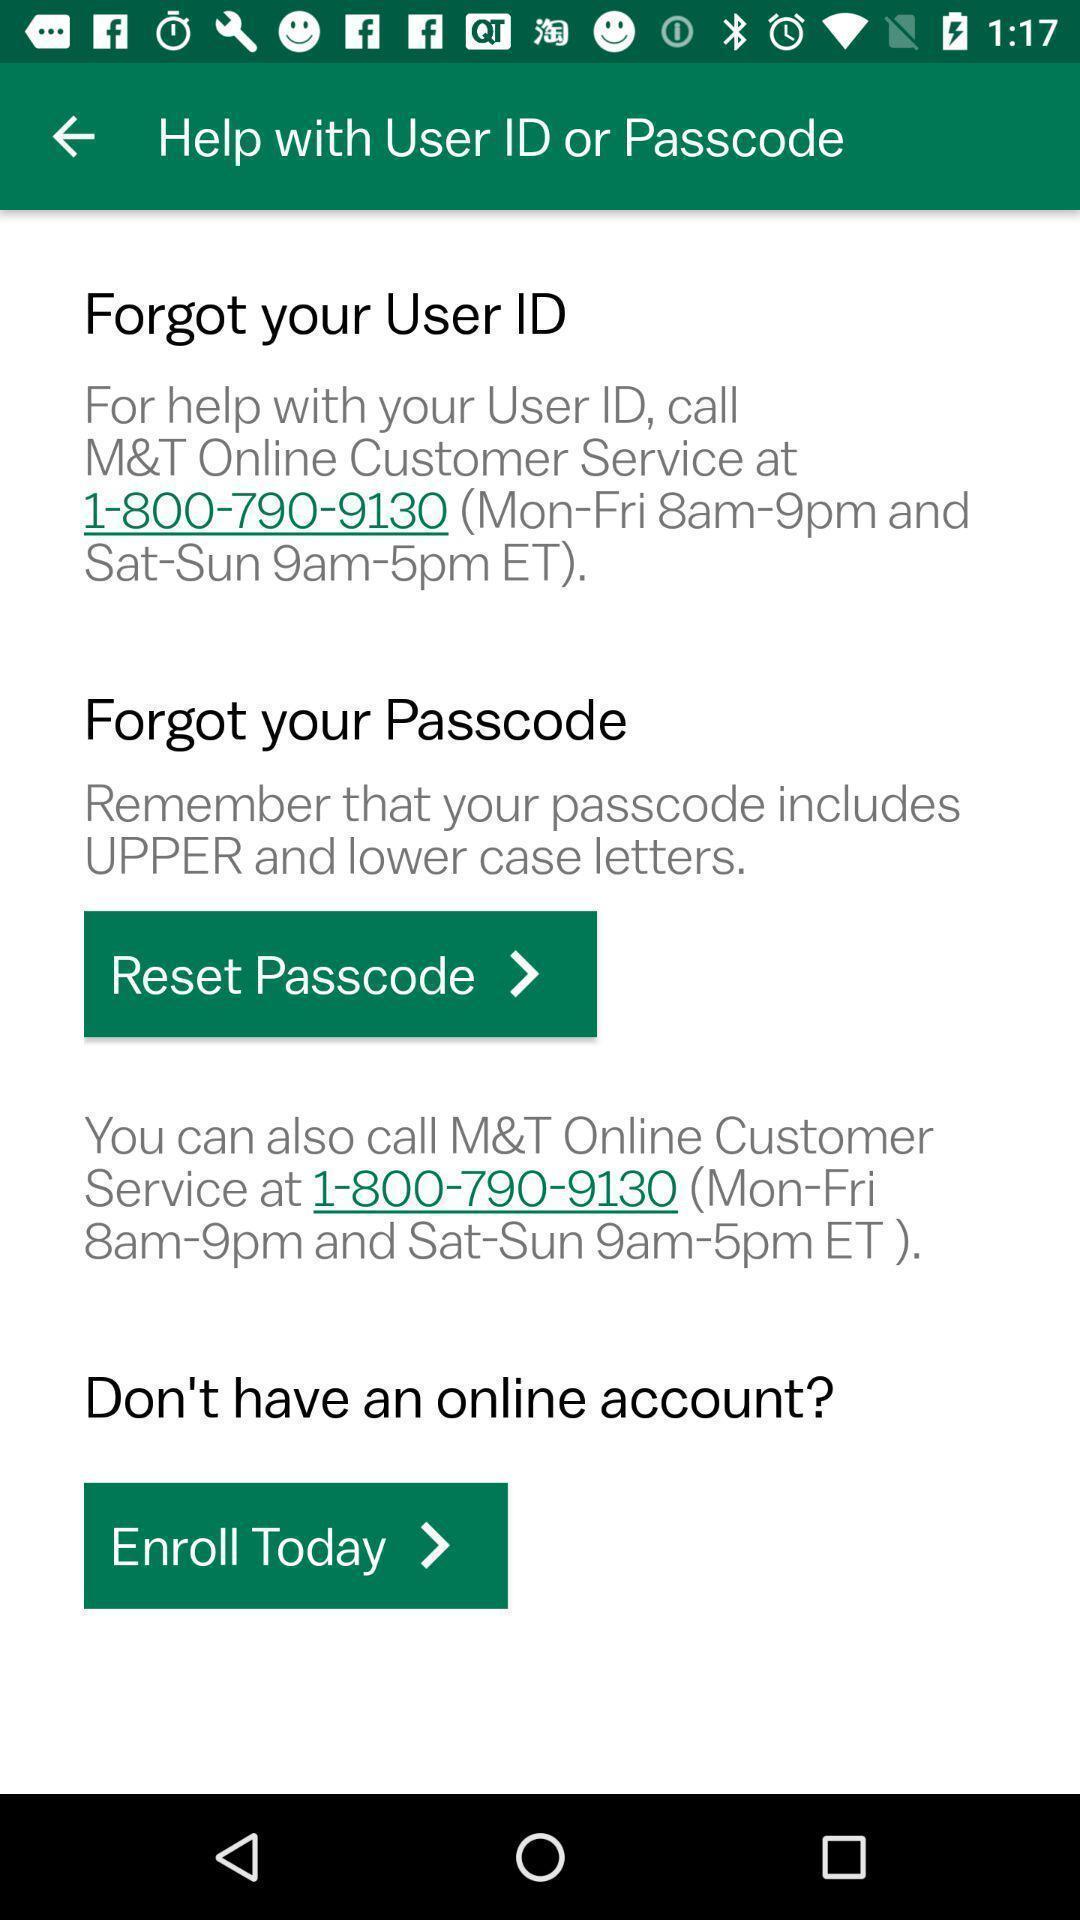Please provide a description for this image. Page showing various buttons. 